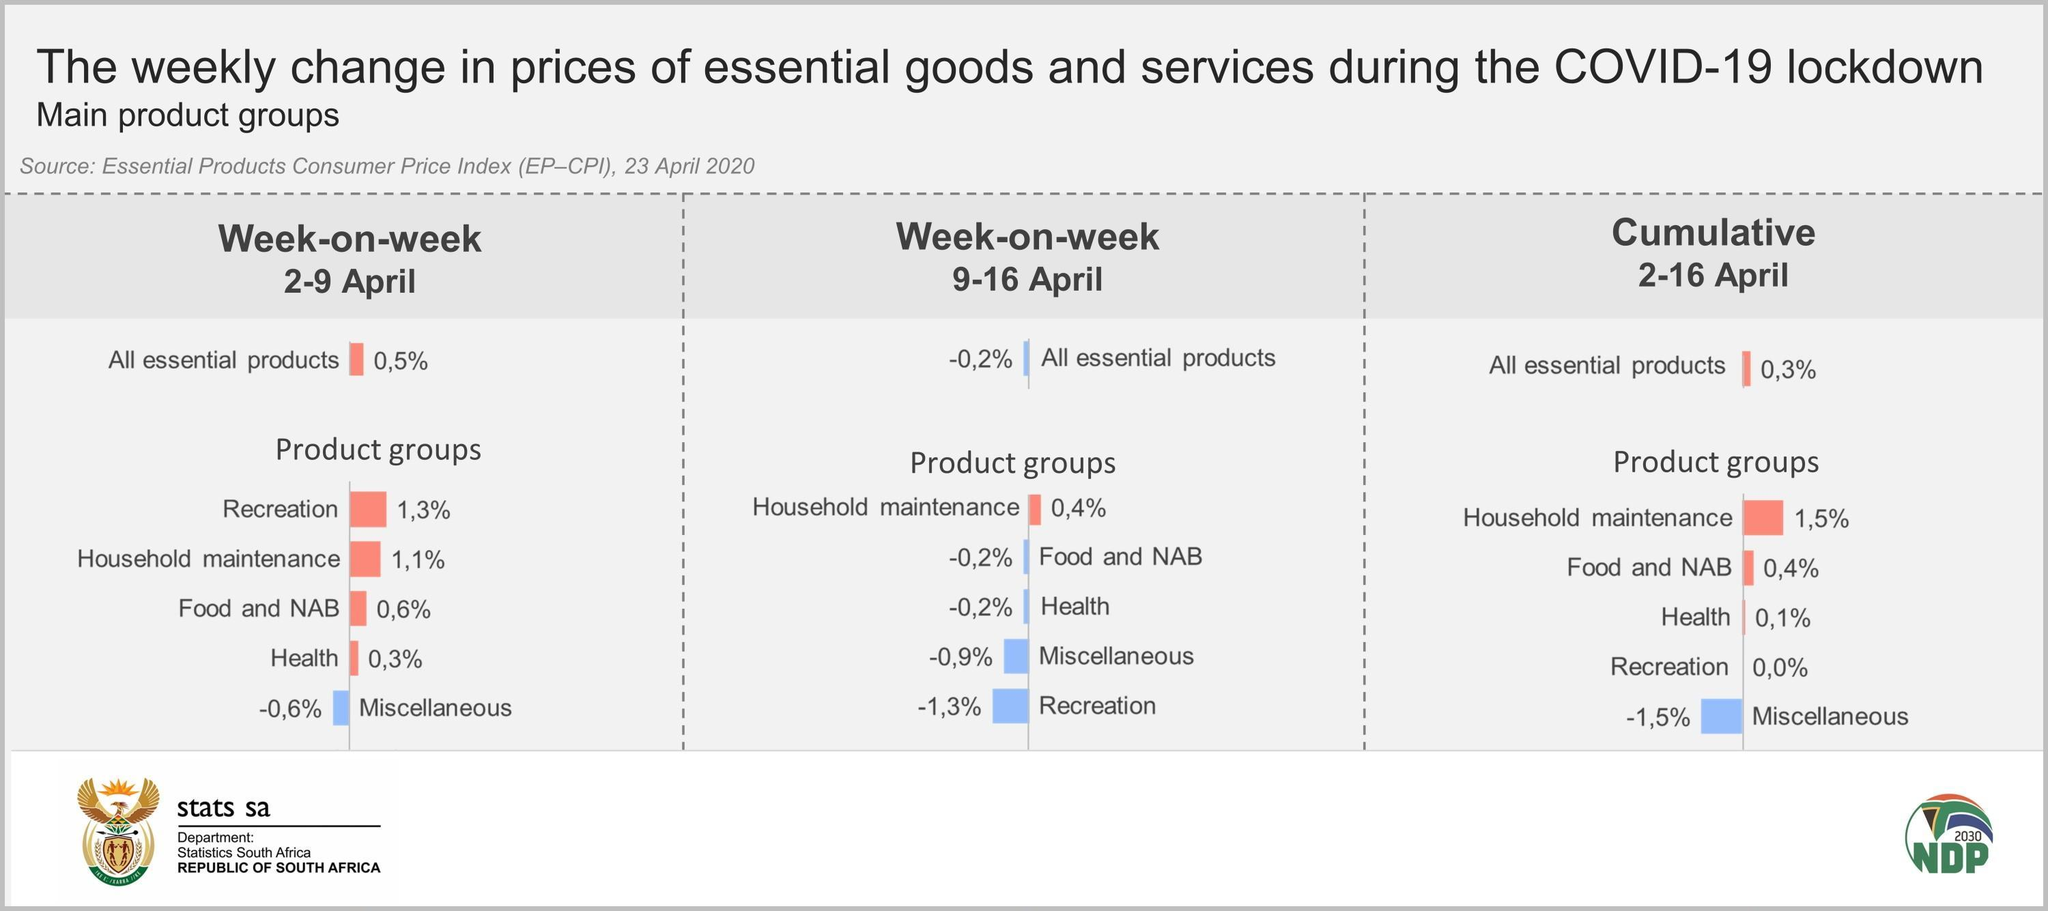in the week of 9-16 April, the price of which product group has decreased in the highest rate?
Answer the question with a short phrase. recreation in the week of 2-9 April, the price of which product group has increased in the lowest rate? health what is the absolute difference in the percentage change of price in household maintenance of the week 2-9 April and 9-16 April? 0.7 in the week of 2-9 April, the price of which product group has decreased? miscellaneous in the week of 9-16 April, the price of which product group has increased? household maintenance what is the absolute difference in the percentage change of price in overall essential products of the week 2-9 April and 9-16 April? 0.7 in the week of 9-16 April, the price of which product group has decreased in the lowest rate? food and NAB what is the absolute difference in the percentage change of price in recreation of the week 2-9 April and 9-16 April? 2.6% what is the absolute difference in the percentage change of price in health of the week 2-9 April and 9-16 April? 0.5% what is the absolute difference in the percentage change of price in food and NAB of the week 2-9 April and 9-16 April? 0.8% in the week of 2-9 April, the price of which product group has increased in the highest rate? recreation 